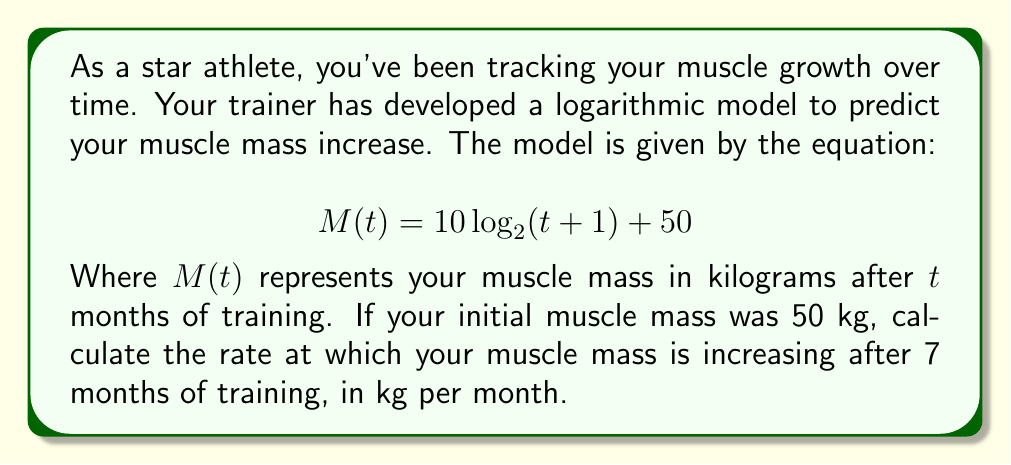Teach me how to tackle this problem. To solve this problem, we need to follow these steps:

1) The rate of change is given by the derivative of the function. So, we need to find $\frac{dM}{dt}$.

2) To differentiate $M(t)$, we use the chain rule:

   $$\frac{dM}{dt} = 10 \cdot \frac{d}{dt}[\log_2(t+1)]$$

3) The derivative of $\log_2(x)$ is $\frac{1}{x \ln 2}$, so:

   $$\frac{dM}{dt} = 10 \cdot \frac{1}{(t+1) \ln 2}$$

4) Now, we need to evaluate this at $t = 7$:

   $$\frac{dM}{dt}\bigg|_{t=7} = 10 \cdot \frac{1}{(7+1) \ln 2} = \frac{10}{8 \ln 2}$$

5) We can calculate this:

   $$\frac{10}{8 \ln 2} \approx 1.80$$

Therefore, after 7 months of training, your muscle mass is increasing at a rate of approximately 1.80 kg per month.
Answer: $1.80$ kg/month 